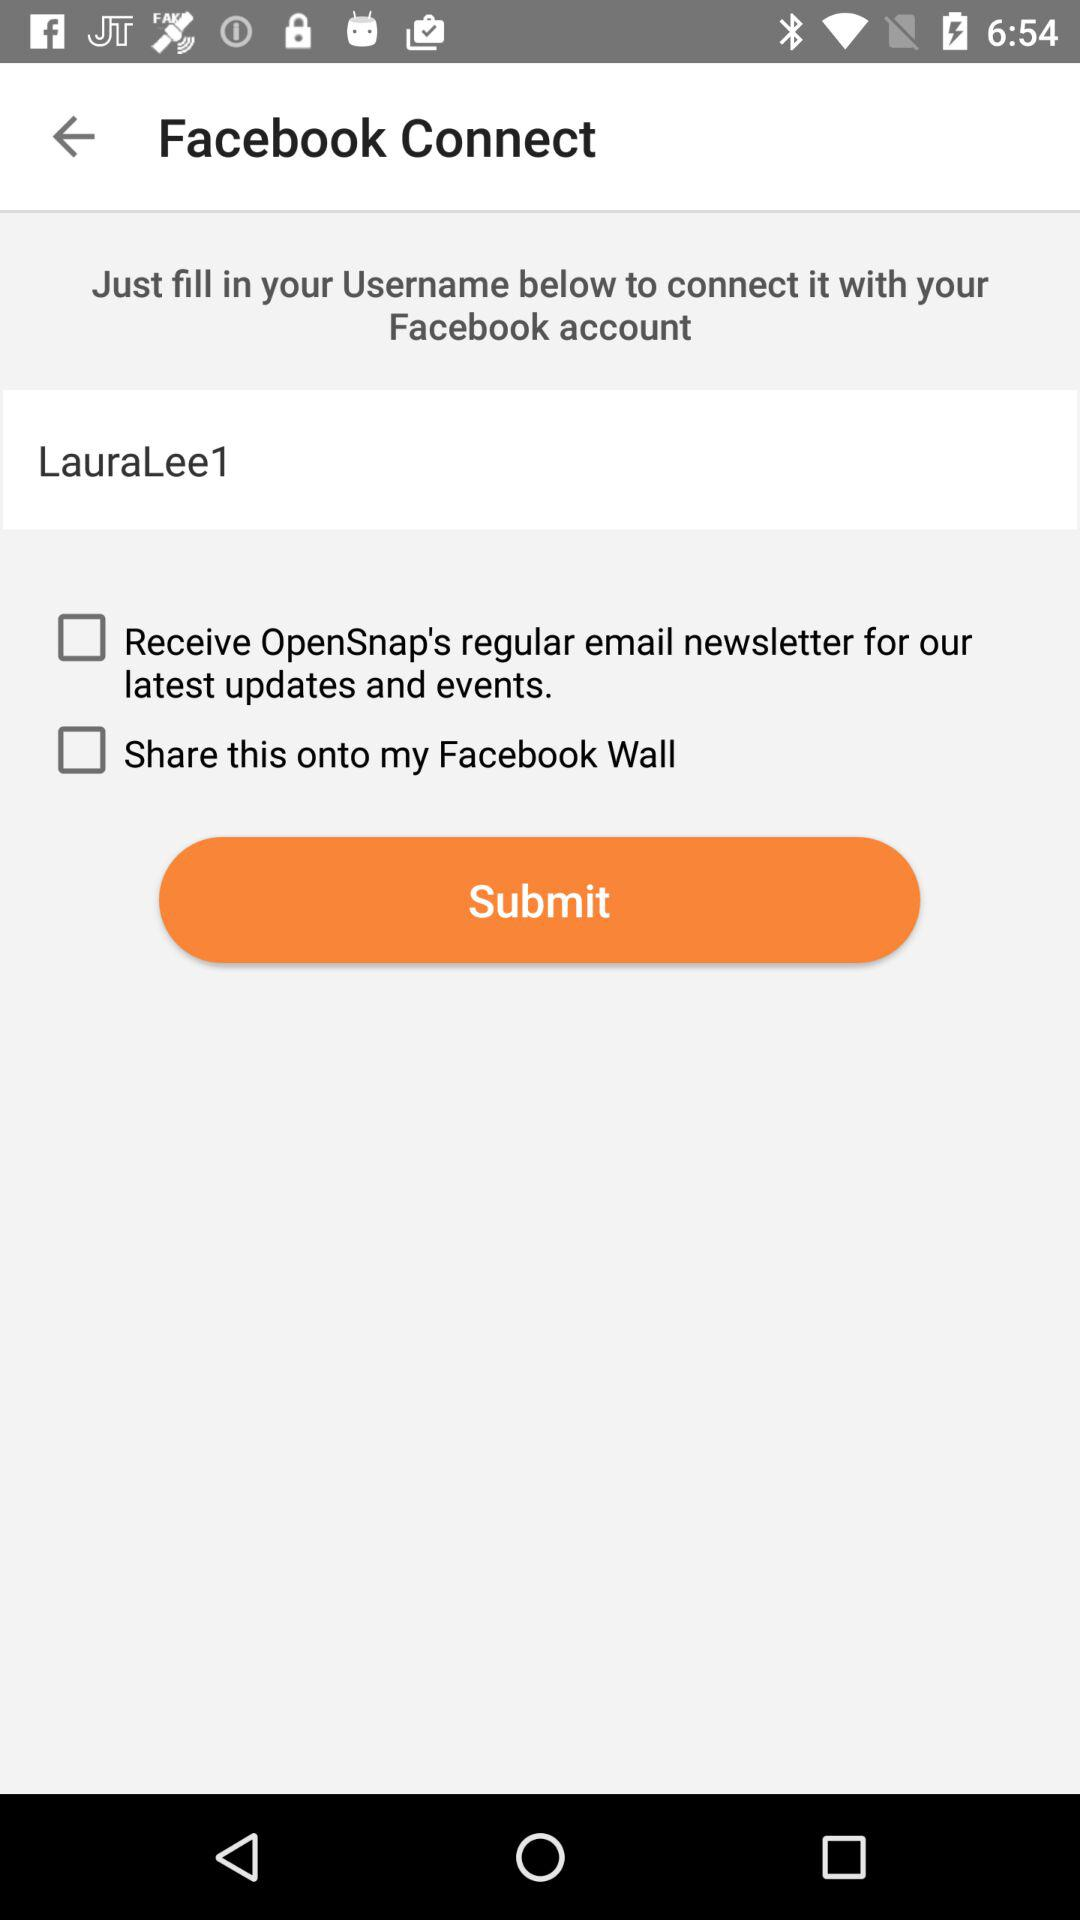What do we need to do to connect it with our "Facebook" account? You need to just fill in your Username below to connect it with your "Facebook" account. 